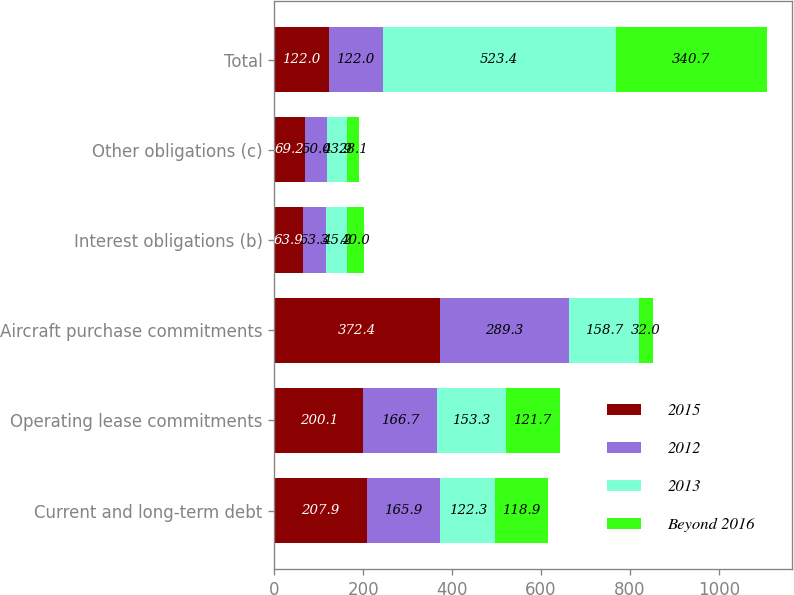<chart> <loc_0><loc_0><loc_500><loc_500><stacked_bar_chart><ecel><fcel>Current and long-term debt<fcel>Operating lease commitments<fcel>Aircraft purchase commitments<fcel>Interest obligations (b)<fcel>Other obligations (c)<fcel>Total<nl><fcel>2015<fcel>207.9<fcel>200.1<fcel>372.4<fcel>63.9<fcel>69.2<fcel>122<nl><fcel>2012<fcel>165.9<fcel>166.7<fcel>289.3<fcel>53.3<fcel>50<fcel>122<nl><fcel>2013<fcel>122.3<fcel>153.3<fcel>158.7<fcel>45.2<fcel>43.9<fcel>523.4<nl><fcel>Beyond 2016<fcel>118.9<fcel>121.7<fcel>32<fcel>40<fcel>28.1<fcel>340.7<nl></chart> 